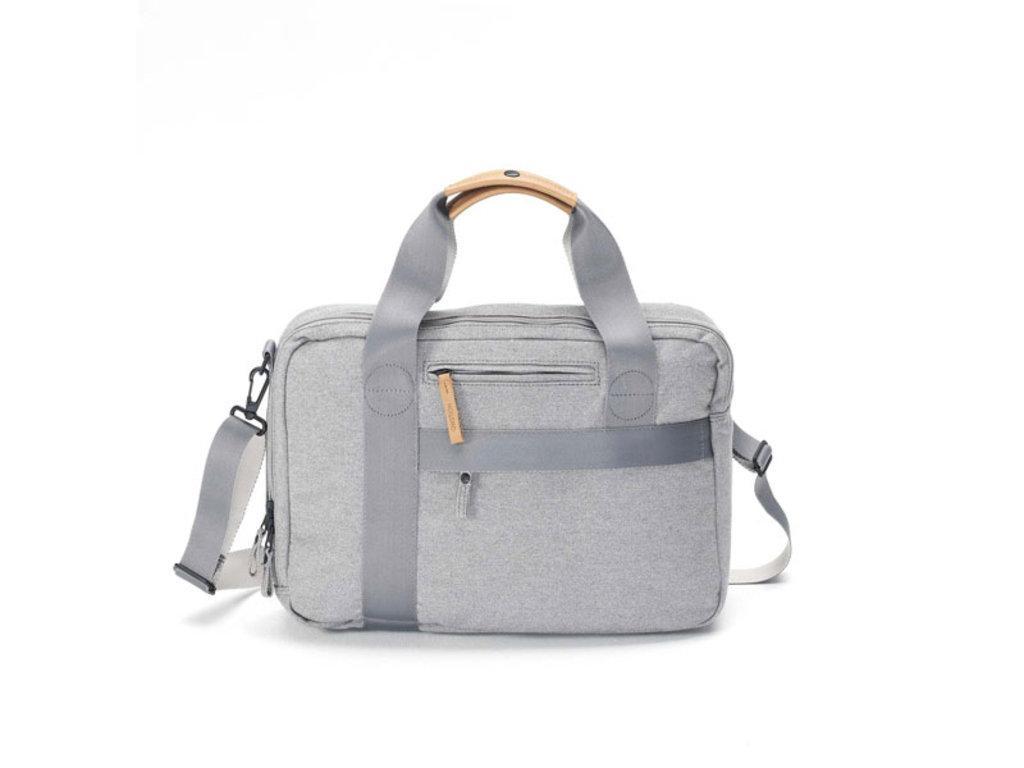Can you describe this image briefly? In this picture we can able to see a gray color handbag with zip. 